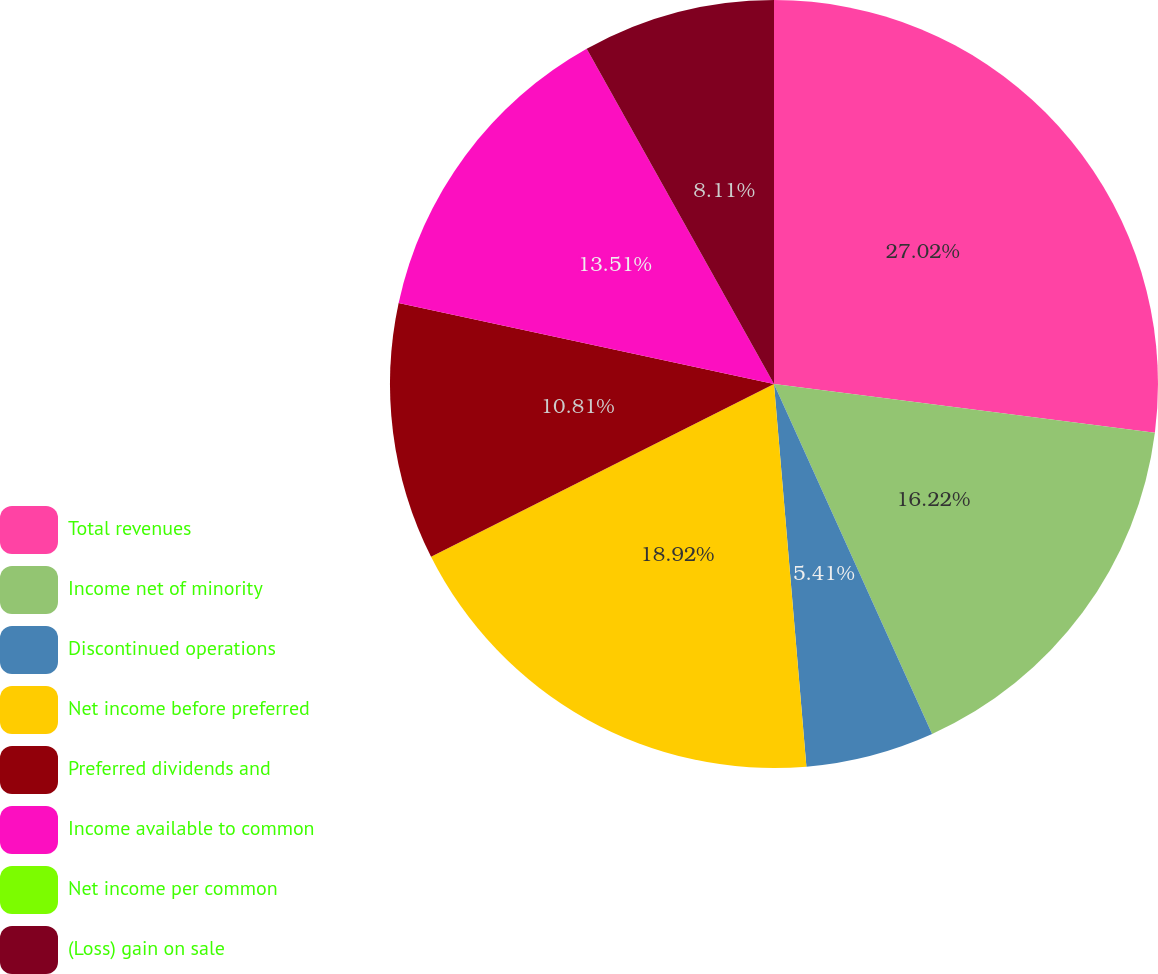Convert chart to OTSL. <chart><loc_0><loc_0><loc_500><loc_500><pie_chart><fcel>Total revenues<fcel>Income net of minority<fcel>Discontinued operations<fcel>Net income before preferred<fcel>Preferred dividends and<fcel>Income available to common<fcel>Net income per common<fcel>(Loss) gain on sale<nl><fcel>27.03%<fcel>16.22%<fcel>5.41%<fcel>18.92%<fcel>10.81%<fcel>13.51%<fcel>0.0%<fcel>8.11%<nl></chart> 